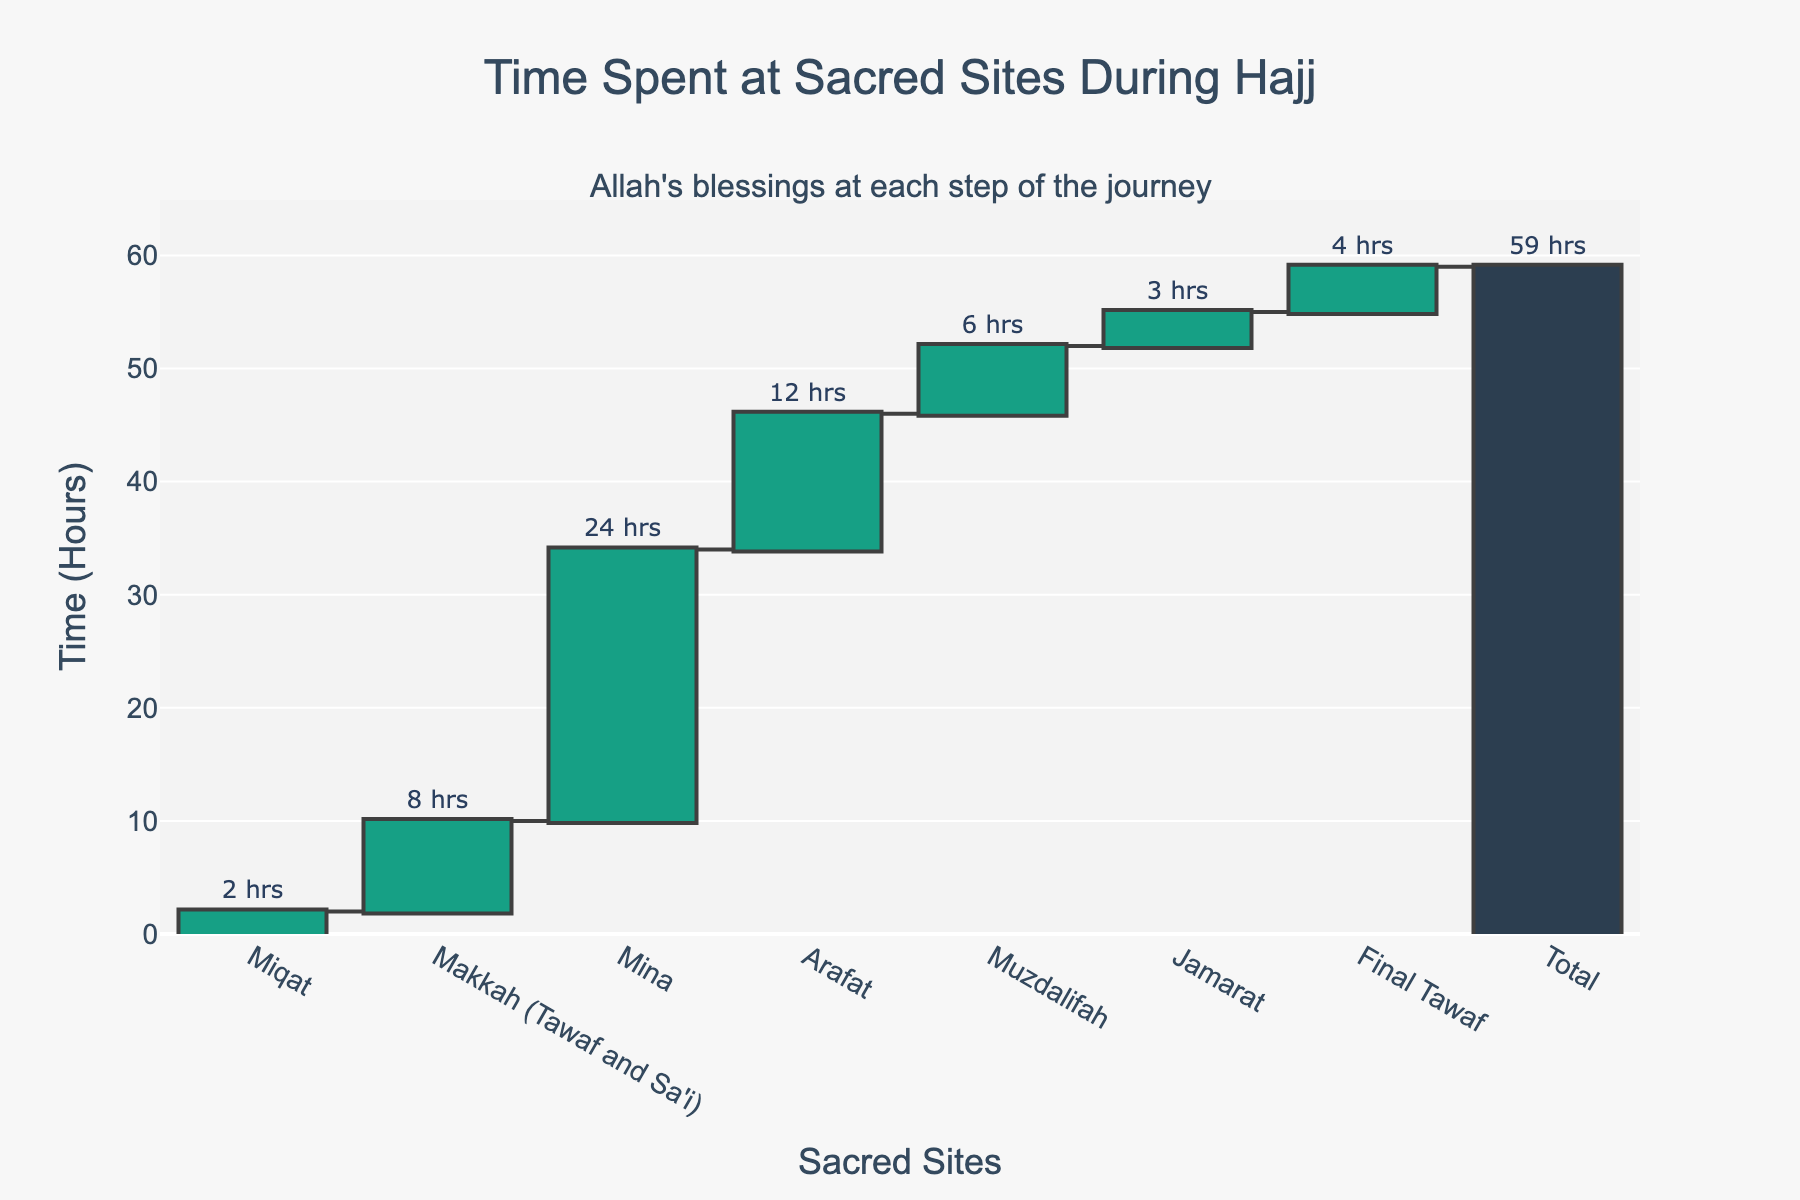What is the title of the figure? The title is usually located at the top center of the figure. In this figure, it reads "Time Spent at Sacred Sites During Hajj".
Answer: Time Spent at Sacred Sites During Hajj How many sacred sites are included in the chart? Count the number of distinct sites shown on the x-axis of the figure.
Answer: 7 Which sacred site requires the most time spent during Hajj? Identify the site with the highest bar in the waterfall chart. In this case, it is Mina with 24 hours.
Answer: Mina What is the total time spent for the Hajj pilgrimage according to the chart? Look at the "Total" bar height in the waterfall chart, which sums up the time spent across all sites. This value is 59 hours.
Answer: 59 hours Which site has the least time spent according to the chart? Identify the site with the smallest bar. In this figure, it is Jamarat with 3 hours.
Answer: Jamarat How much more time is spent at Mina compared to Muzdalifah? Subtract the time spent at Muzdalifah from the time spent at Mina: 24 - 6 = 18 hours.
Answer: 18 hours What is the difference in time spent between Makkah (Tawaf and Sa'i) and Arafat? Subtract the time spent at Arafat from the time spent at Makkah (Tawaf and Sa'i): 8 - 12 = -4 hours. This means 4 hours less are spent at Makkah (Tawaf and Sa'i) than at Arafat.
Answer: 4 hours less at Makkah Is the time spent at Arafat more than at Muzdalifah? Compare the heights of the bars for Arafat and Muzdalifah. Arafat has 12 hours, which is greater than Muzdalifah's 6 hours.
Answer: Yes What is the average time spent across all sacred sites excluding the final total? Sum the time spent across all the individual sites (2 + 8 + 24 + 12 + 6 + 3 + 4 = 59) and divide by the number of sites (7). The average is 59/7 ≈ 8.43 hours.
Answer: 8.43 hours How much more time is spent at Final Tawaf compared to Miqat? Subtract the time spent at Miqat from the time spent at Final Tawaf: 4 - 2 = 2 hours.
Answer: 2 hours 